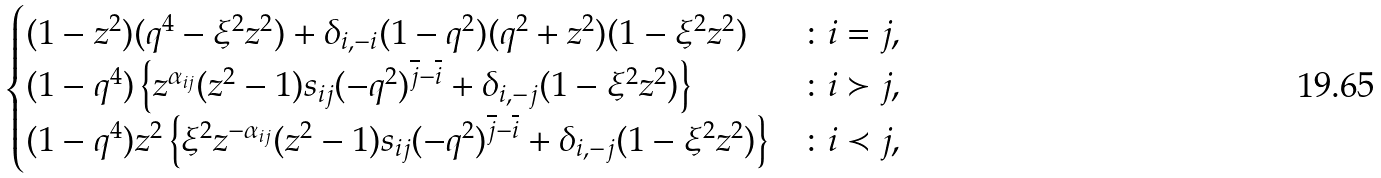<formula> <loc_0><loc_0><loc_500><loc_500>\begin{cases} ( 1 - z ^ { 2 } ) ( q ^ { 4 } - \xi ^ { 2 } z ^ { 2 } ) + \delta _ { i , - i } ( 1 - q ^ { 2 } ) ( q ^ { 2 } + z ^ { 2 } ) ( 1 - \xi ^ { 2 } z ^ { 2 } ) & \colon i = j , \\ ( 1 - q ^ { 4 } ) \left \{ z ^ { \alpha _ { i j } } ( z ^ { 2 } - 1 ) s _ { i j } ( - q ^ { 2 } ) ^ { \overline { j } - \overline { i } } + \delta _ { i , - j } ( 1 - \xi ^ { 2 } z ^ { 2 } ) \right \} & \colon i \succ j , \\ ( 1 - q ^ { 4 } ) z ^ { 2 } \left \{ \xi ^ { 2 } z ^ { - \alpha _ { i j } } ( z ^ { 2 } - 1 ) s _ { i j } ( - q ^ { 2 } ) ^ { \overline { j } - \overline { i } } + \delta _ { i , - j } ( 1 - \xi ^ { 2 } z ^ { 2 } ) \right \} & \colon i \prec j , \end{cases}</formula> 